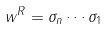<formula> <loc_0><loc_0><loc_500><loc_500>w ^ { R } = \sigma _ { n } \cdots \sigma _ { 1 }</formula> 